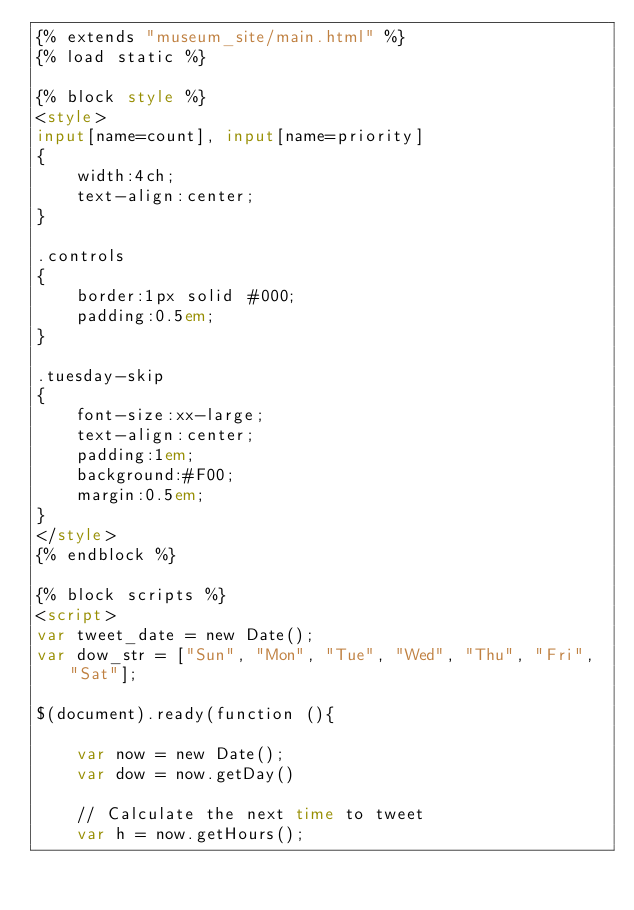<code> <loc_0><loc_0><loc_500><loc_500><_HTML_>{% extends "museum_site/main.html" %}
{% load static %}

{% block style %}
<style>
input[name=count], input[name=priority]
{
    width:4ch;
    text-align:center;
}

.controls
{
    border:1px solid #000;
    padding:0.5em;
}

.tuesday-skip
{
    font-size:xx-large;
    text-align:center;
    padding:1em;
    background:#F00;
    margin:0.5em;
}
</style>
{% endblock %}

{% block scripts %}
<script>
var tweet_date = new Date();
var dow_str = ["Sun", "Mon", "Tue", "Wed", "Thu", "Fri", "Sat"];

$(document).ready(function (){

    var now = new Date();
    var dow = now.getDay()

    // Calculate the next time to tweet
    var h = now.getHours();</code> 